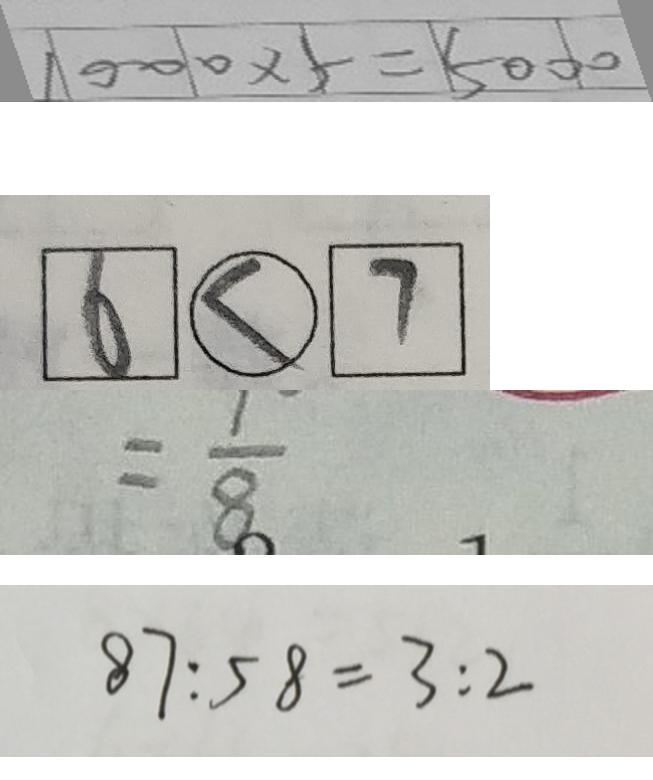Convert formula to latex. <formula><loc_0><loc_0><loc_500><loc_500>1 0 0 0 \times 5 = 5 0 0 0 
 \boxed { 6 } \textcircled { < } \boxed { 7 } 
 = \frac { 1 } { 8 } 
 8 7 : 5 8 = 3 : 2</formula> 